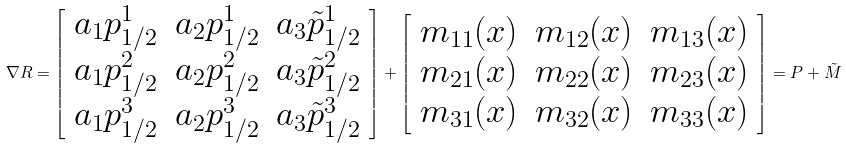Convert formula to latex. <formula><loc_0><loc_0><loc_500><loc_500>\nabla R = \left [ \begin{array} { l l l } a _ { 1 } p _ { 1 / 2 } ^ { 1 } & a _ { 2 } p _ { 1 / 2 } ^ { 1 } & a _ { 3 } \tilde { p } _ { 1 / 2 } ^ { 1 } \\ a _ { 1 } p _ { 1 / 2 } ^ { 2 } & a _ { 2 } p _ { 1 / 2 } ^ { 2 } & a _ { 3 } \tilde { p } _ { 1 / 2 } ^ { 2 } \\ a _ { 1 } p _ { 1 / 2 } ^ { 3 } & a _ { 2 } p _ { 1 / 2 } ^ { 3 } & a _ { 3 } \tilde { p } _ { 1 / 2 } ^ { 3 } \end{array} \right ] + \left [ \begin{array} { l l l } m _ { 1 1 } ( x ) & m _ { 1 2 } ( x ) & m _ { 1 3 } ( x ) \\ m _ { 2 1 } ( x ) & m _ { 2 2 } ( x ) & m _ { 2 3 } ( x ) \\ m _ { 3 1 } ( x ) & m _ { 3 2 } ( x ) & m _ { 3 3 } ( x ) \end{array} \right ] = P + \tilde { M }</formula> 